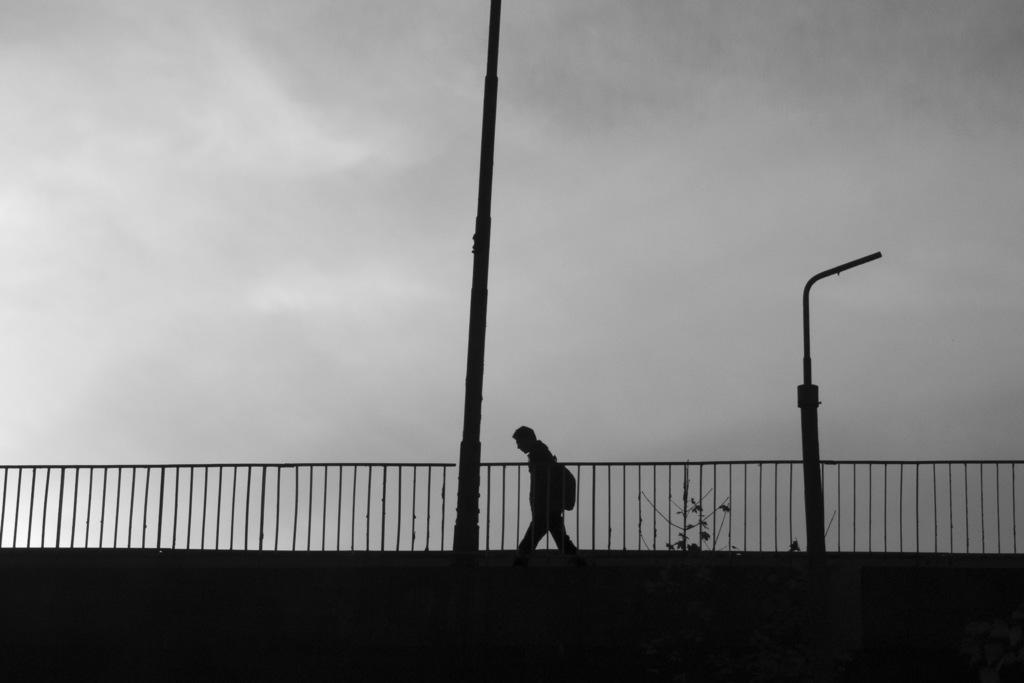What is the person in the image doing? The person in the image is carrying a bag. What structures can be seen in the image? There are poles and a fence in the image. What type of vegetation is present in the image? There are plants in the image. What is visible in the background of the image? The sky is visible in the image. What type of cakes are being used as chess pieces in the image? There are no cakes or chess pieces present in the image. 